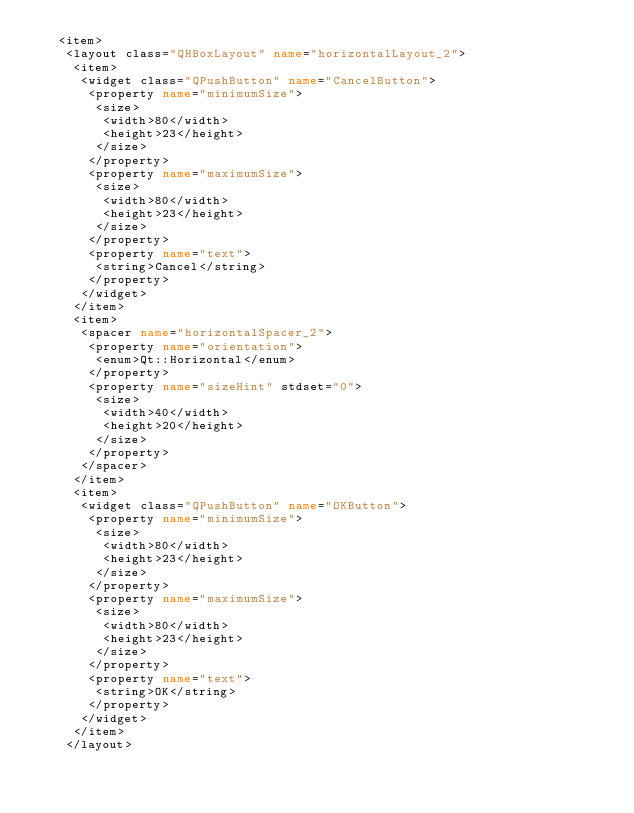<code> <loc_0><loc_0><loc_500><loc_500><_XML_>   <item>
    <layout class="QHBoxLayout" name="horizontalLayout_2">
     <item>
      <widget class="QPushButton" name="CancelButton">
       <property name="minimumSize">
        <size>
         <width>80</width>
         <height>23</height>
        </size>
       </property>
       <property name="maximumSize">
        <size>
         <width>80</width>
         <height>23</height>
        </size>
       </property>
       <property name="text">
        <string>Cancel</string>
       </property>
      </widget>
     </item>
     <item>
      <spacer name="horizontalSpacer_2">
       <property name="orientation">
        <enum>Qt::Horizontal</enum>
       </property>
       <property name="sizeHint" stdset="0">
        <size>
         <width>40</width>
         <height>20</height>
        </size>
       </property>
      </spacer>
     </item>
     <item>
      <widget class="QPushButton" name="OKButton">
       <property name="minimumSize">
        <size>
         <width>80</width>
         <height>23</height>
        </size>
       </property>
       <property name="maximumSize">
        <size>
         <width>80</width>
         <height>23</height>
        </size>
       </property>
       <property name="text">
        <string>OK</string>
       </property>
      </widget>
     </item>
    </layout></code> 